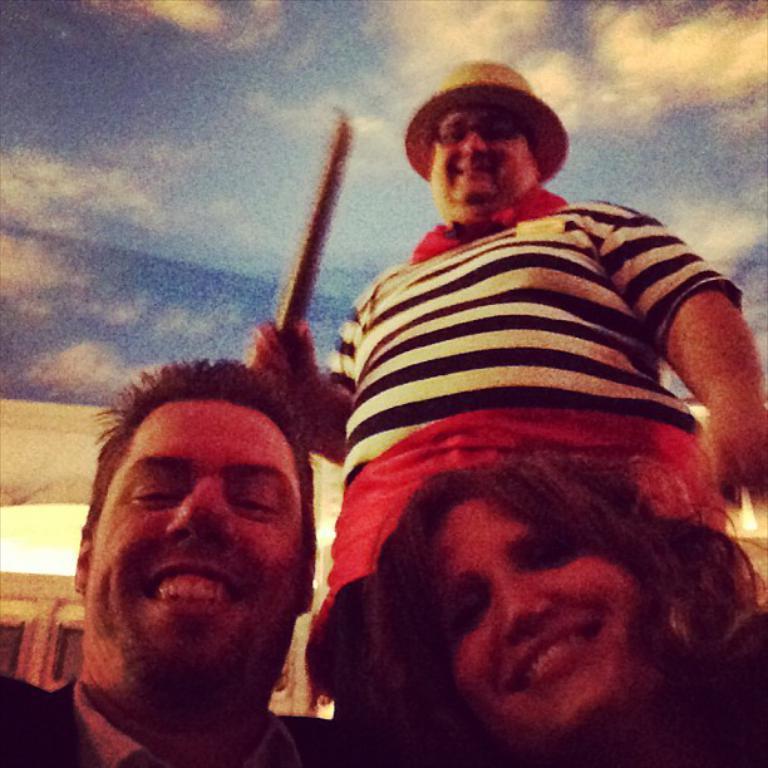Please provide a concise description of this image. In this image we can see a man wearing a hat and holding an object. We can also see another man smiling and also a woman in this image. In the background we can see the building and also the sky with the clouds. 